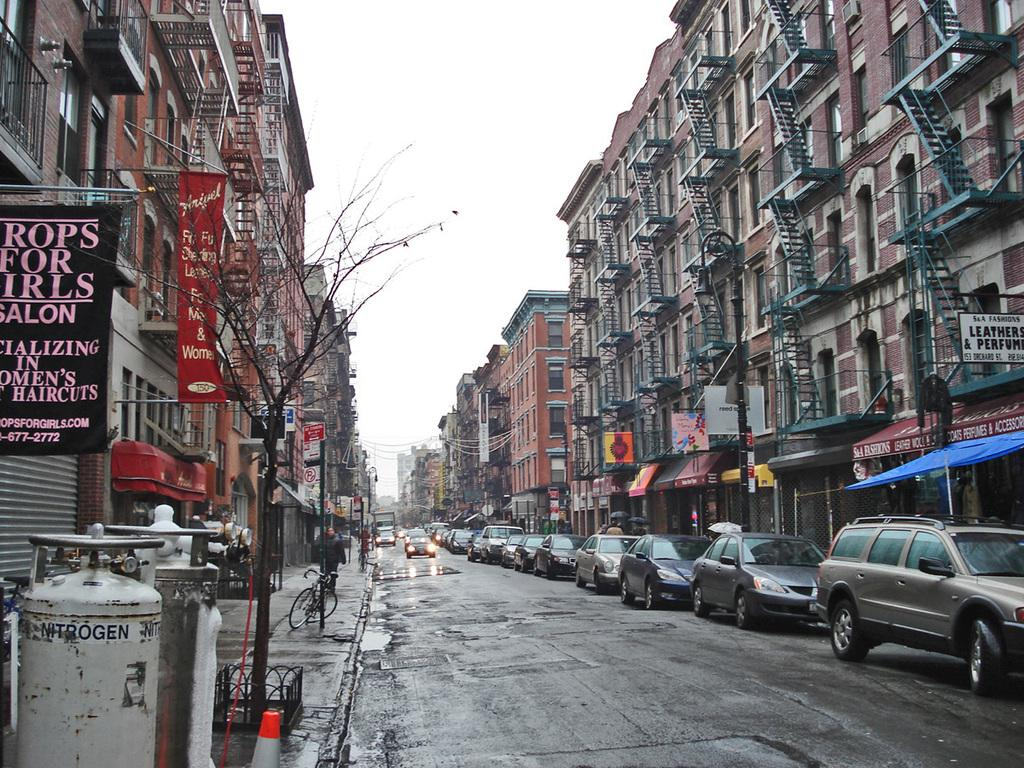What can be seen on the road in the image? There are many vehicles on the road in the image. What is visible on both sides of the road in the image? There are buildings on either side of the road in the image. How many snails can be seen on the road in the image? There are no snails visible on the road in the image. What is the profit of the buildings in the image? The image does not provide information about the profit of the buildings. 